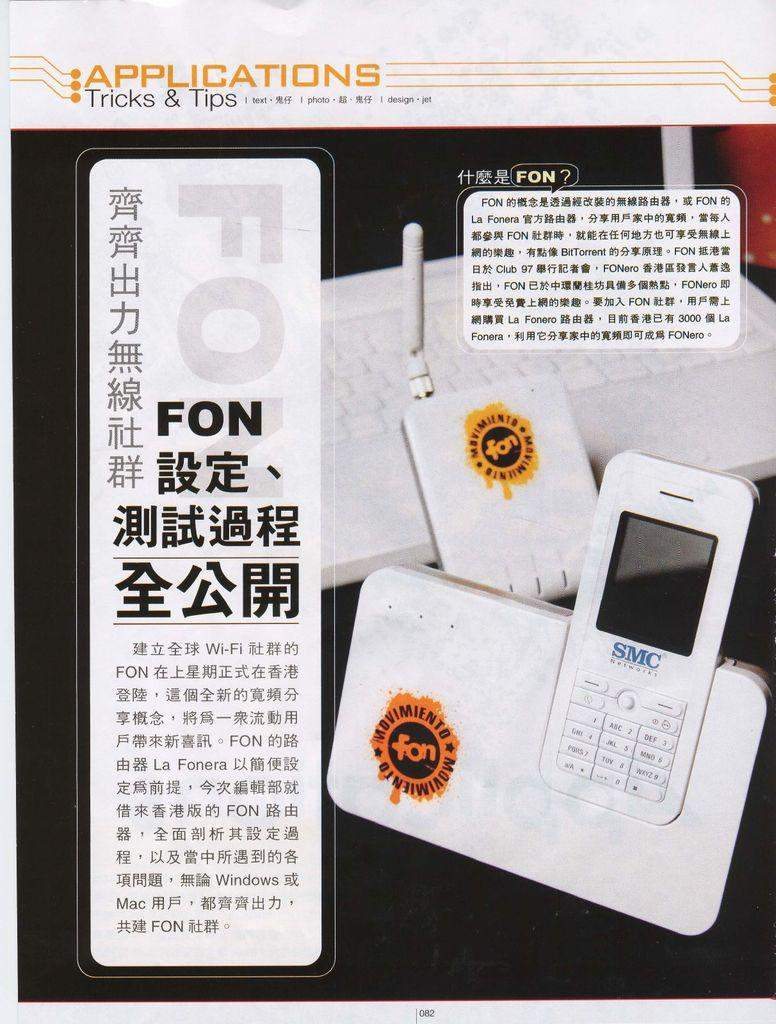Provide a one-sentence caption for the provided image. An applications tricks and tips page for a phone written in an Asian language. 